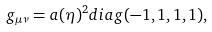<formula> <loc_0><loc_0><loc_500><loc_500>g _ { \mu \nu } = a ( \eta ) ^ { 2 } d i a g ( - 1 , 1 , 1 , 1 ) ,</formula> 